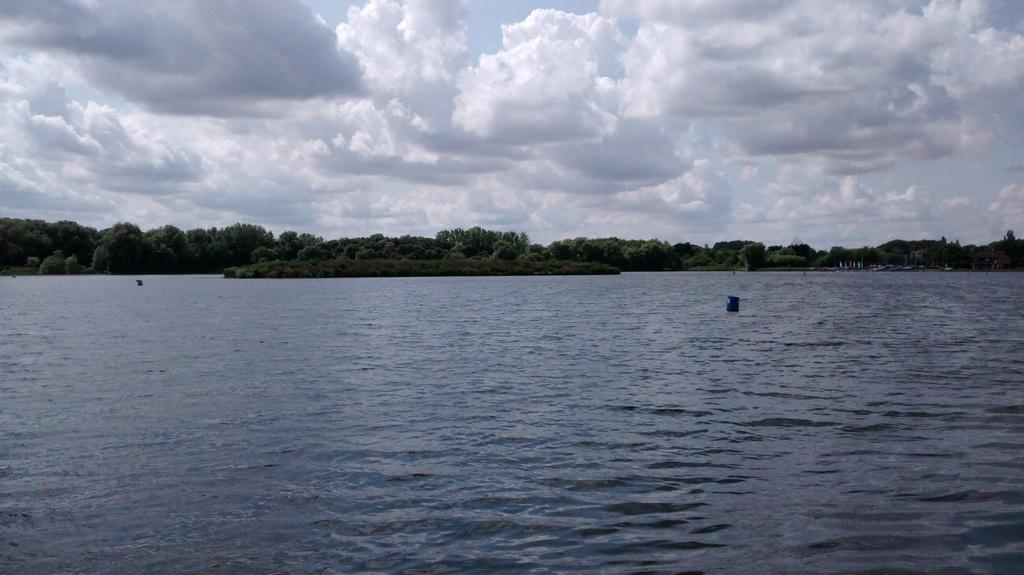What is visible in the image? Water, trees, and the sky are visible in the image. Can you describe the sky in the image? The sky is cloudy in the image. What type of natural environment is depicted in the image? The image features water, trees, and a cloudy sky, which suggests a natural setting. Can you tell me how many yaks are visible in the image? There are no yaks present in the image. Was the cloudy sky caused by an earthquake in the image? There is no indication of an earthquake in the image; it simply shows a cloudy sky. 